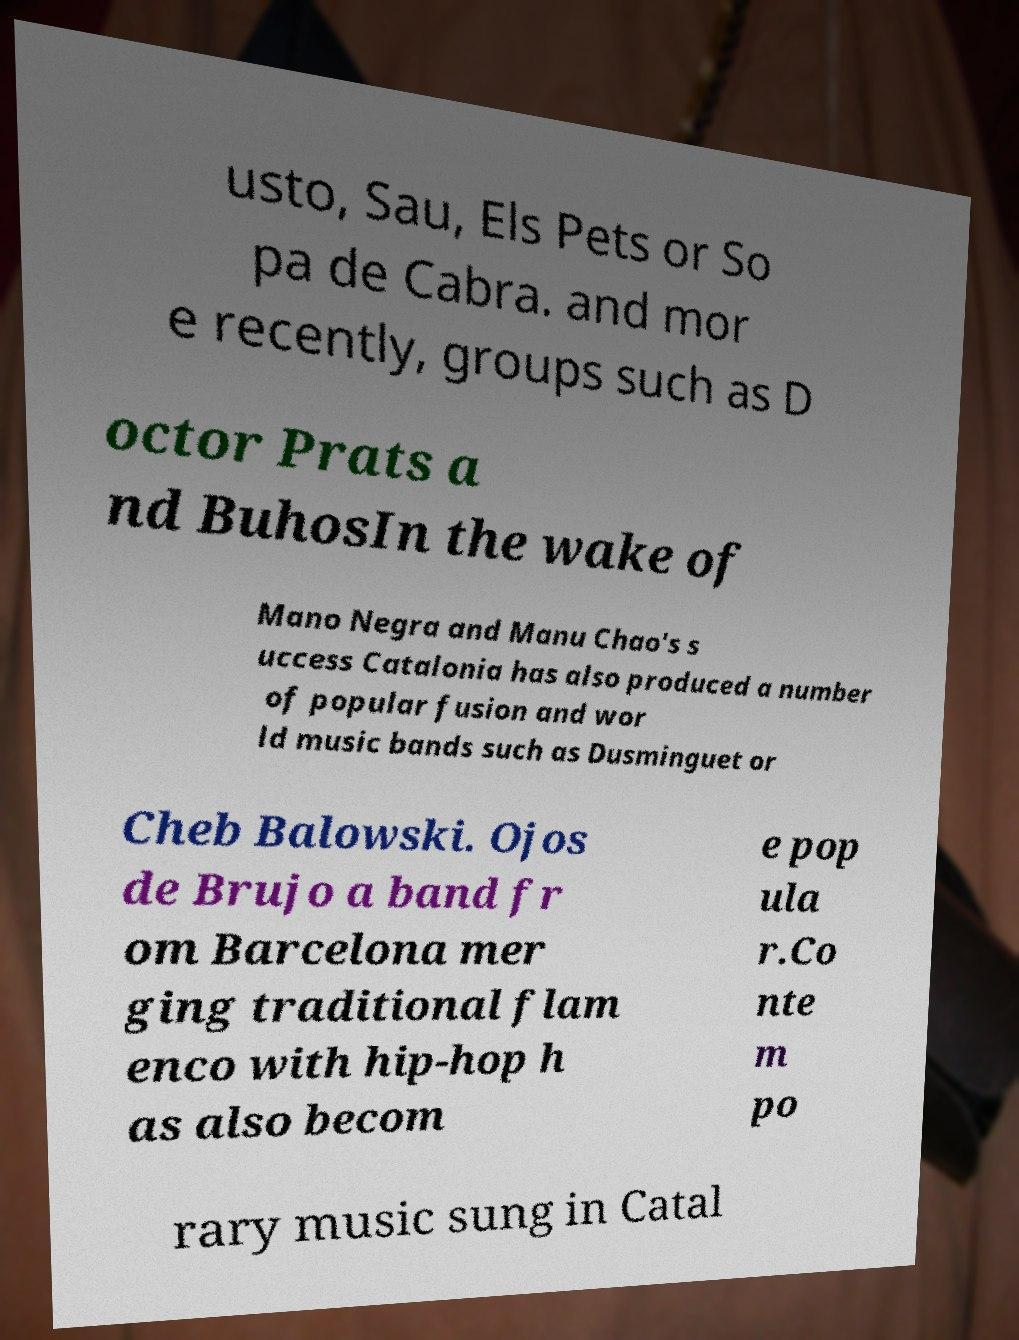Please identify and transcribe the text found in this image. usto, Sau, Els Pets or So pa de Cabra. and mor e recently, groups such as D octor Prats a nd BuhosIn the wake of Mano Negra and Manu Chao's s uccess Catalonia has also produced a number of popular fusion and wor ld music bands such as Dusminguet or Cheb Balowski. Ojos de Brujo a band fr om Barcelona mer ging traditional flam enco with hip-hop h as also becom e pop ula r.Co nte m po rary music sung in Catal 